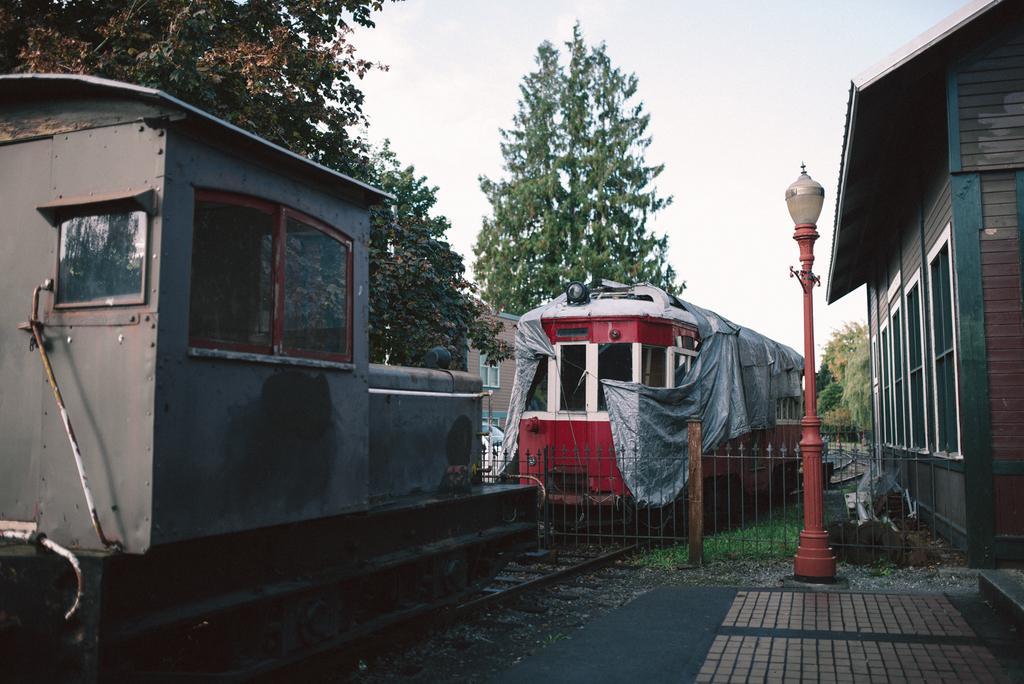In one or two sentences, can you explain what this image depicts? In this image, we can see trains on the track. Here we can see railing, light pole, path, houses, trees, grass and few objects. Background we can see the sky. 